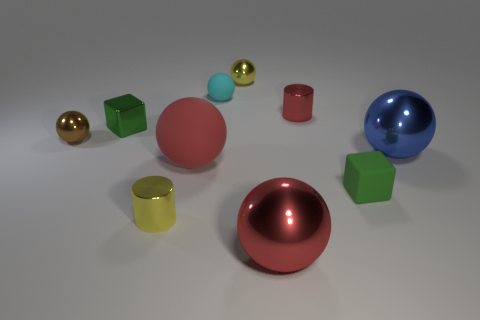What size is the other block that is the same color as the tiny rubber cube?
Give a very brief answer. Small. Is there any other thing that has the same material as the large blue thing?
Your answer should be compact. Yes. Is the material of the tiny cylinder that is to the right of the small yellow metallic sphere the same as the cyan object?
Offer a very short reply. No. Is the number of green cubes right of the big rubber thing less than the number of tiny matte cubes?
Give a very brief answer. No. What number of metallic things are tiny blocks or large blue balls?
Your answer should be compact. 2. Is the big rubber thing the same color as the tiny matte cube?
Give a very brief answer. No. Is there anything else that has the same color as the metallic cube?
Make the answer very short. Yes. Do the tiny yellow metallic object behind the cyan object and the big thing that is right of the small red shiny object have the same shape?
Your response must be concise. Yes. How many things are either metal objects or small green cubes right of the metallic cube?
Your answer should be compact. 8. How many other objects are the same size as the red rubber sphere?
Keep it short and to the point. 2. 